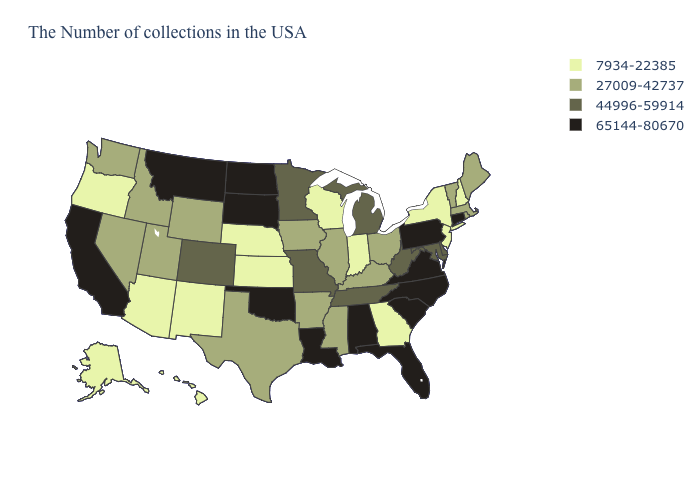What is the lowest value in states that border North Carolina?
Write a very short answer. 7934-22385. Which states have the lowest value in the West?
Keep it brief. New Mexico, Arizona, Oregon, Alaska, Hawaii. Does the map have missing data?
Be succinct. No. What is the highest value in the USA?
Short answer required. 65144-80670. What is the value of Illinois?
Be succinct. 27009-42737. Does Kentucky have a lower value than Mississippi?
Quick response, please. No. Does Oklahoma have a higher value than Louisiana?
Keep it brief. No. What is the value of Pennsylvania?
Answer briefly. 65144-80670. Among the states that border Texas , which have the lowest value?
Short answer required. New Mexico. What is the lowest value in the USA?
Concise answer only. 7934-22385. What is the lowest value in the Northeast?
Give a very brief answer. 7934-22385. Which states have the lowest value in the USA?
Keep it brief. New Hampshire, New York, New Jersey, Georgia, Indiana, Wisconsin, Kansas, Nebraska, New Mexico, Arizona, Oregon, Alaska, Hawaii. What is the lowest value in the USA?
Keep it brief. 7934-22385. What is the value of New Mexico?
Short answer required. 7934-22385. Name the states that have a value in the range 7934-22385?
Concise answer only. New Hampshire, New York, New Jersey, Georgia, Indiana, Wisconsin, Kansas, Nebraska, New Mexico, Arizona, Oregon, Alaska, Hawaii. 